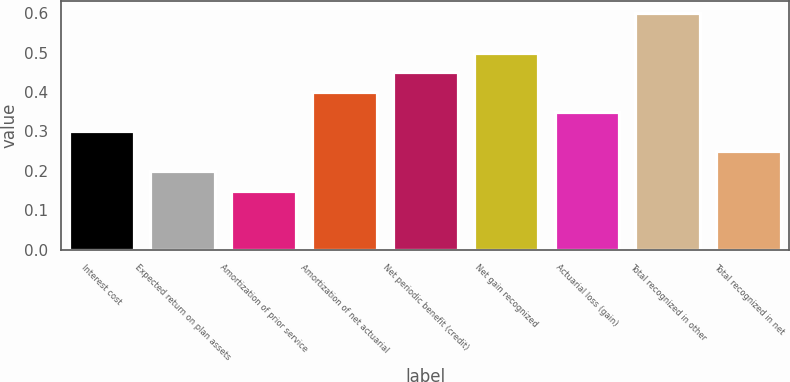Convert chart to OTSL. <chart><loc_0><loc_0><loc_500><loc_500><bar_chart><fcel>Interest cost<fcel>Expected return on plan assets<fcel>Amortization of prior service<fcel>Amortization of net actuarial<fcel>Net periodic benefit (credit)<fcel>Net gain recognized<fcel>Actuarial loss (gain)<fcel>Total recognized in other<fcel>Total recognized in net<nl><fcel>0.3<fcel>0.2<fcel>0.15<fcel>0.4<fcel>0.45<fcel>0.5<fcel>0.35<fcel>0.6<fcel>0.25<nl></chart> 